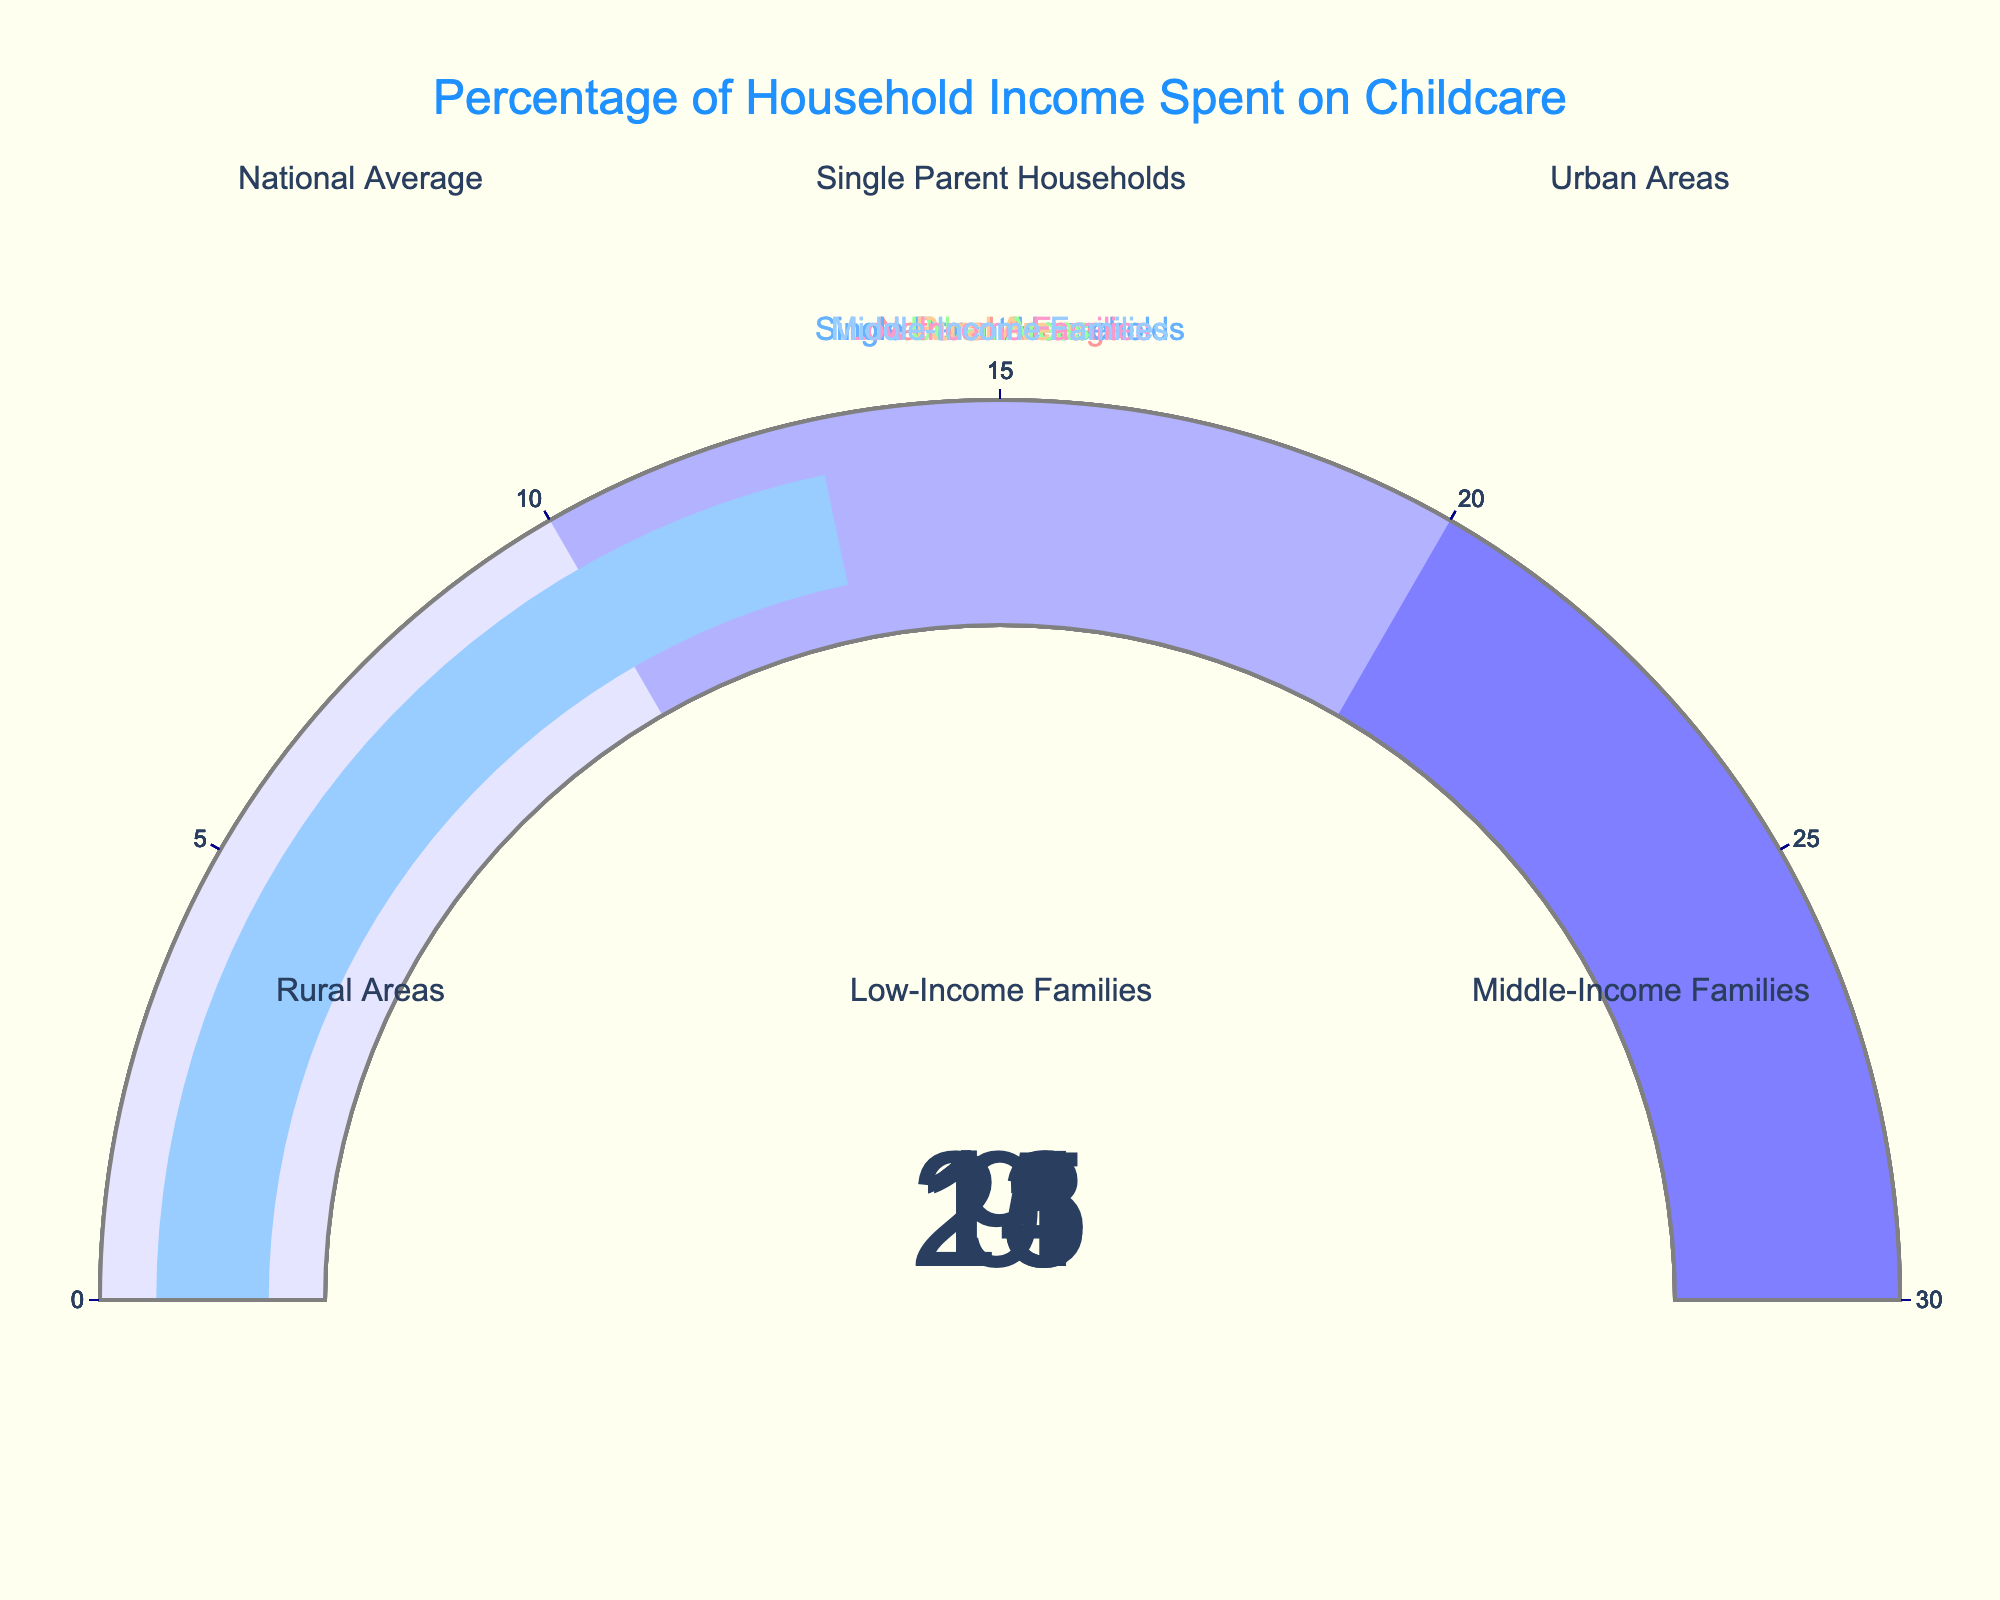What is the title of the figure? The title is displayed at the top center of the figure. It reads "Percentage of Household Income Spent on Childcare."
Answer: Percentage of Household Income Spent on Childcare How many categories are shown in the figure? Each gauge represents a category, and there are six gauges in total.
Answer: 6 Which category has the highest percentage of household income spent on childcare? The gauge for "Low-Income Families" shows the highest value, which is 25%.
Answer: Low-Income Families What is the value displayed for Single Parent Households? The value for Single Parent Households is shown on one of the gauges. It is 18%.
Answer: 18% What is the difference in percentage spending between Urban Areas and Rural Areas? The value for Urban Areas is 14% and for Rural Areas is 9%. Subtracting the two gives 14 - 9 = 5%.
Answer: 5% Which category spends exactly twice the percentage of household income on childcare compared to Rural Areas? The value for Rural Areas is 9%. The category with a value that is twice this is 18%, which is displayed by Single Parent Households.
Answer: Single Parent Households What is the average percentage of household income spent on childcare across all categories? Add all the percentages: 11 (National Average) + 18 (Single Parent Households) + 14 (Urban Areas) + 9 (Rural Areas) + 25 (Low-Income Families) + 13 (Middle-Income Families) = 90. Divide by the number of categories, which is 6. The average is 90 / 6 = 15%.
Answer: 15% How much more do Low-Income Families spend on childcare as a percentage of income compared to the National Average? Low-Income Families spend 25%, and the National Average is 11%. Subtracting the latter from the former gives 25 - 11 = 14%.
Answer: 14% Which category falls closest to the midpoint value on the gauge? The gauge has a range from 0 to 30, so the midpoint is 15%. The value for Middle-Income Families is closest to 15%, at 13%.
Answer: Middle-Income Families If adding up the childcare spending percentages of all Urban and Rural Areas, what would be the total? The percentage for Urban Areas is 14%, and for Rural Areas, it is 9%. Adding them up gives 14 + 9 = 23%.
Answer: 23% 